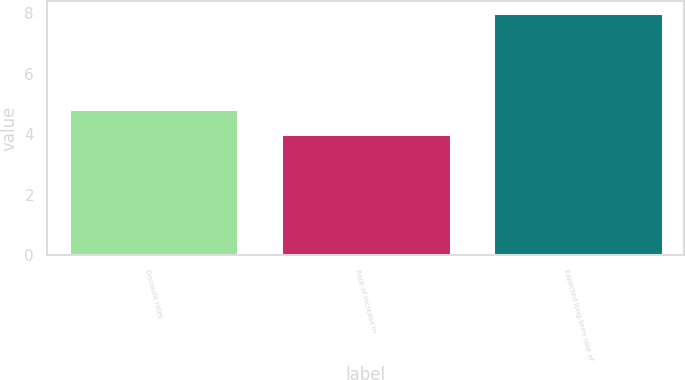<chart> <loc_0><loc_0><loc_500><loc_500><bar_chart><fcel>Discount rates<fcel>Rate of increase in<fcel>Expected long-term rate of<nl><fcel>4.82<fcel>4<fcel>8<nl></chart> 